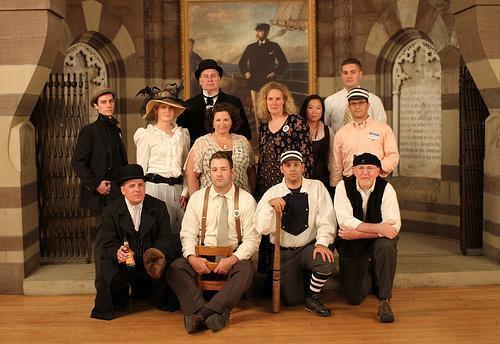How many people are wearing glasses?
Give a very brief answer. 2. 